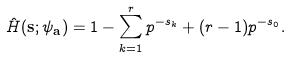<formula> <loc_0><loc_0><loc_500><loc_500>\hat { H } ( \mathbf s ; \psi _ { \mathbf a } ) = 1 - \sum _ { k = 1 } ^ { r } p ^ { - s _ { k } } + ( r - 1 ) p ^ { - s _ { 0 } } .</formula> 